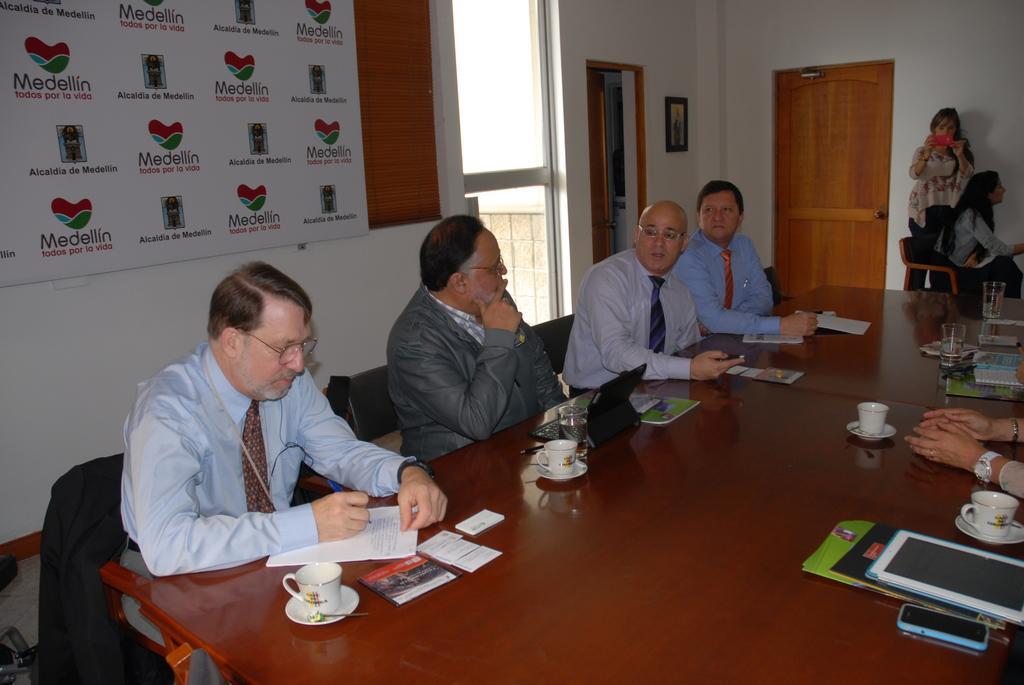How would you summarize this image in a sentence or two? In this picture there are group of people they are sitting around the table, by resting their hands on the table and there is a window and a door at the left side of the image, there is a girl who is standing at the right side of the image, she is taking the video. 